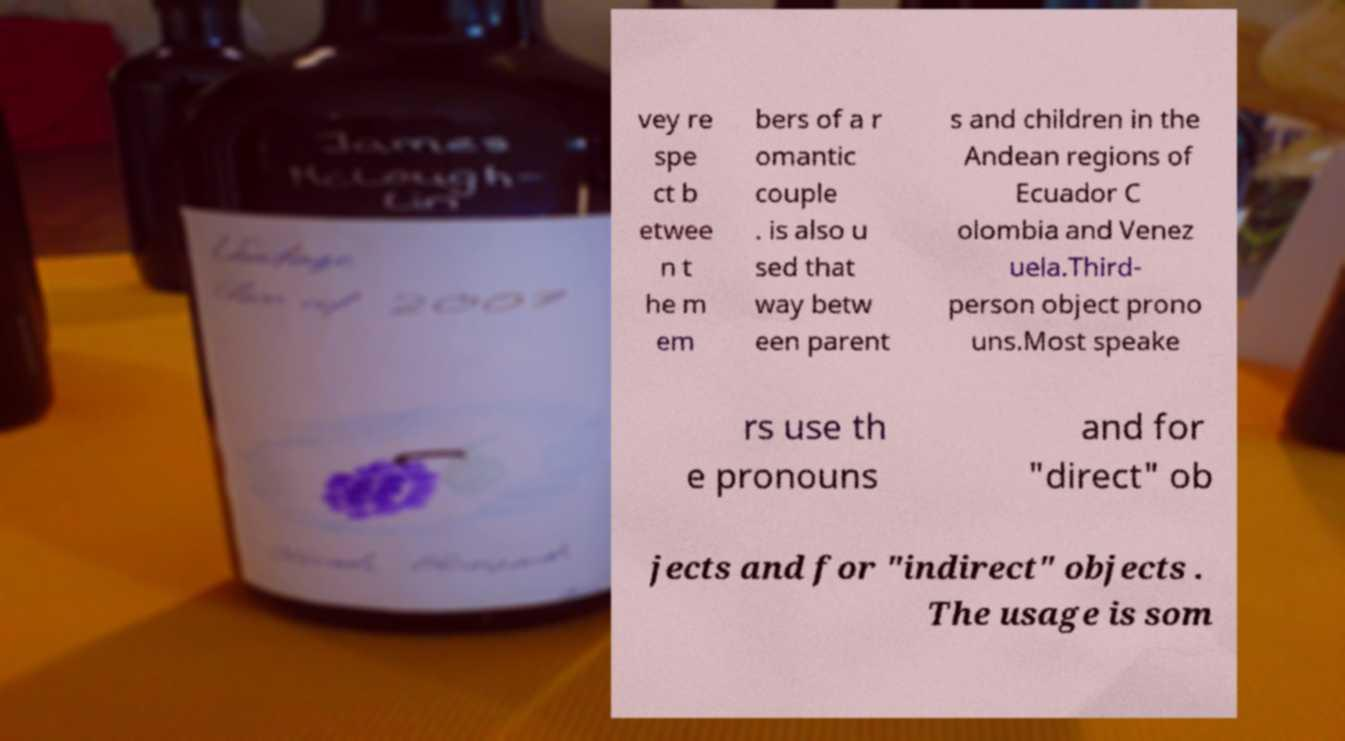Can you read and provide the text displayed in the image?This photo seems to have some interesting text. Can you extract and type it out for me? vey re spe ct b etwee n t he m em bers of a r omantic couple . is also u sed that way betw een parent s and children in the Andean regions of Ecuador C olombia and Venez uela.Third- person object prono uns.Most speake rs use th e pronouns and for "direct" ob jects and for "indirect" objects . The usage is som 